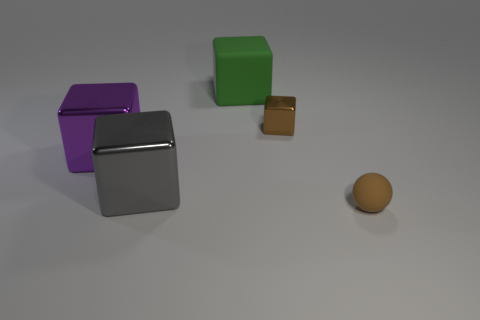Are the tiny brown thing that is in front of the small brown metallic object and the block that is on the right side of the green block made of the same material?
Offer a very short reply. No. What shape is the rubber object in front of the rubber thing that is behind the cube that is right of the large green object?
Ensure brevity in your answer.  Sphere. Is the number of large gray metal objects greater than the number of yellow spheres?
Ensure brevity in your answer.  Yes. Is there a large cyan object?
Provide a short and direct response. No. How many objects are shiny objects in front of the green block or big matte things behind the brown rubber ball?
Provide a short and direct response. 4. Does the tiny block have the same color as the matte sphere?
Your answer should be compact. Yes. Are there fewer metal things than tiny gray metallic balls?
Give a very brief answer. No. There is a ball; are there any small objects behind it?
Ensure brevity in your answer.  Yes. Are the brown cube and the sphere made of the same material?
Your answer should be compact. No. There is another matte object that is the same shape as the large gray object; what color is it?
Give a very brief answer. Green. 